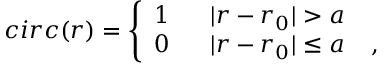<formula> <loc_0><loc_0><loc_500><loc_500>c i r c ( r ) = \left \{ \begin{array} { l l } { 1 \, | r - r _ { 0 } | > a } \\ { 0 \, | r - r _ { 0 } | \leq a \, , } \end{array}</formula> 